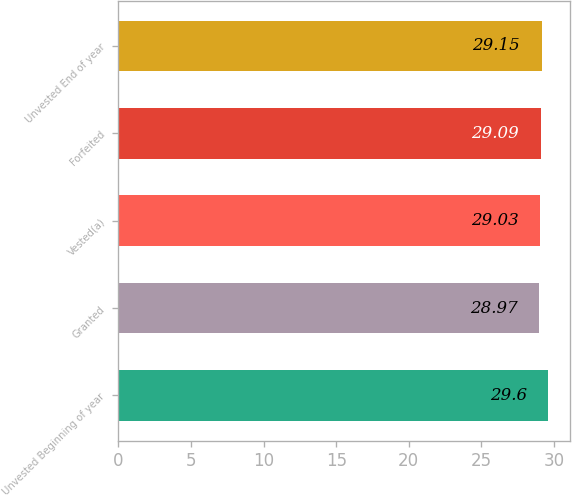<chart> <loc_0><loc_0><loc_500><loc_500><bar_chart><fcel>Unvested Beginning of year<fcel>Granted<fcel>Vested(a)<fcel>Forfeited<fcel>Unvested End of year<nl><fcel>29.6<fcel>28.97<fcel>29.03<fcel>29.09<fcel>29.15<nl></chart> 